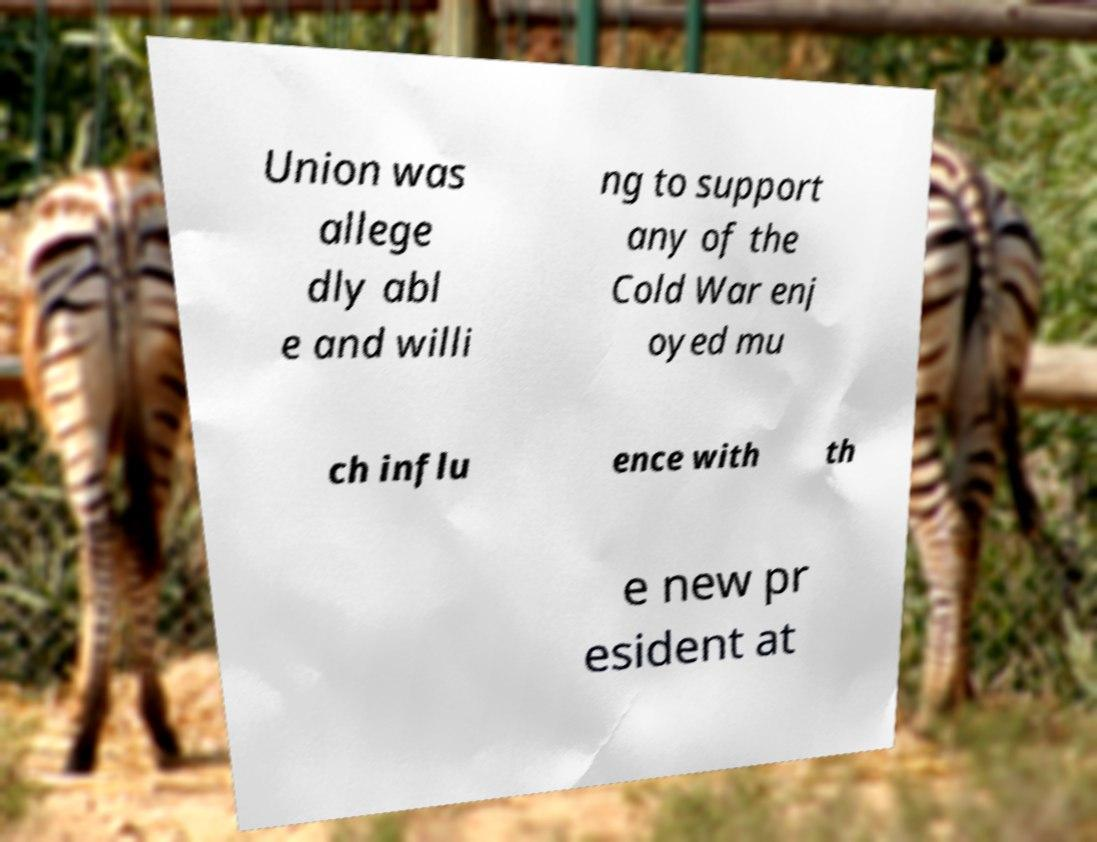Please read and relay the text visible in this image. What does it say? Union was allege dly abl e and willi ng to support any of the Cold War enj oyed mu ch influ ence with th e new pr esident at 